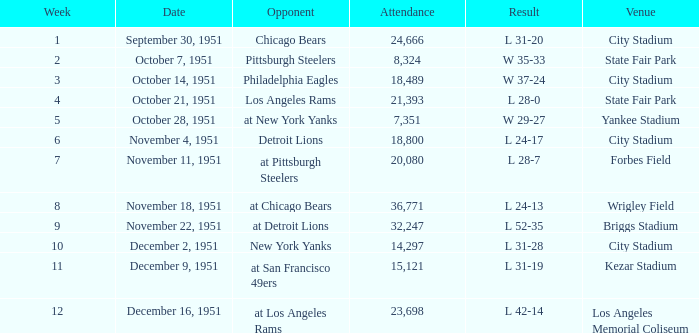Help me parse the entirety of this table. {'header': ['Week', 'Date', 'Opponent', 'Attendance', 'Result', 'Venue'], 'rows': [['1', 'September 30, 1951', 'Chicago Bears', '24,666', 'L 31-20', 'City Stadium'], ['2', 'October 7, 1951', 'Pittsburgh Steelers', '8,324', 'W 35-33', 'State Fair Park'], ['3', 'October 14, 1951', 'Philadelphia Eagles', '18,489', 'W 37-24', 'City Stadium'], ['4', 'October 21, 1951', 'Los Angeles Rams', '21,393', 'L 28-0', 'State Fair Park'], ['5', 'October 28, 1951', 'at New York Yanks', '7,351', 'W 29-27', 'Yankee Stadium'], ['6', 'November 4, 1951', 'Detroit Lions', '18,800', 'L 24-17', 'City Stadium'], ['7', 'November 11, 1951', 'at Pittsburgh Steelers', '20,080', 'L 28-7', 'Forbes Field'], ['8', 'November 18, 1951', 'at Chicago Bears', '36,771', 'L 24-13', 'Wrigley Field'], ['9', 'November 22, 1951', 'at Detroit Lions', '32,247', 'L 52-35', 'Briggs Stadium'], ['10', 'December 2, 1951', 'New York Yanks', '14,297', 'L 31-28', 'City Stadium'], ['11', 'December 9, 1951', 'at San Francisco 49ers', '15,121', 'L 31-19', 'Kezar Stadium'], ['12', 'December 16, 1951', 'at Los Angeles Rams', '23,698', 'L 42-14', 'Los Angeles Memorial Coliseum']]} On which date at city stadium, with an attendance of over 14,297, was the week number greater than 4? November 4, 1951. 